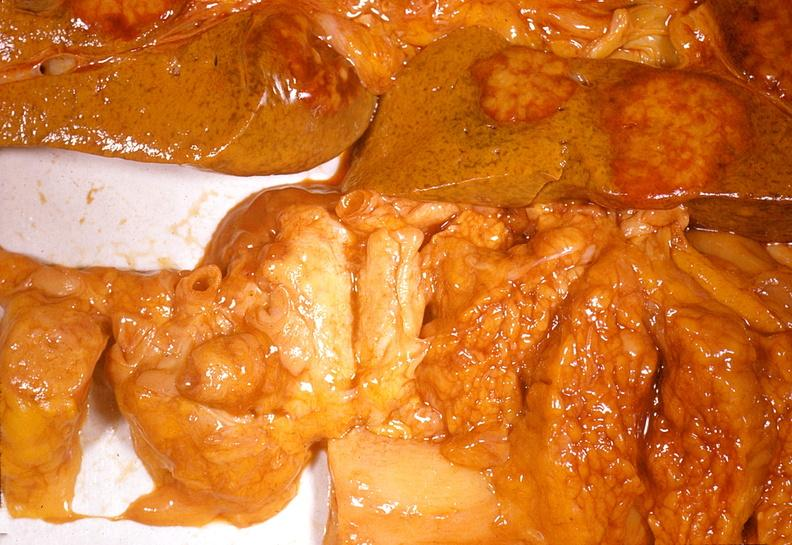does this image show adenocarcinoma, body of pancreas?
Answer the question using a single word or phrase. Yes 